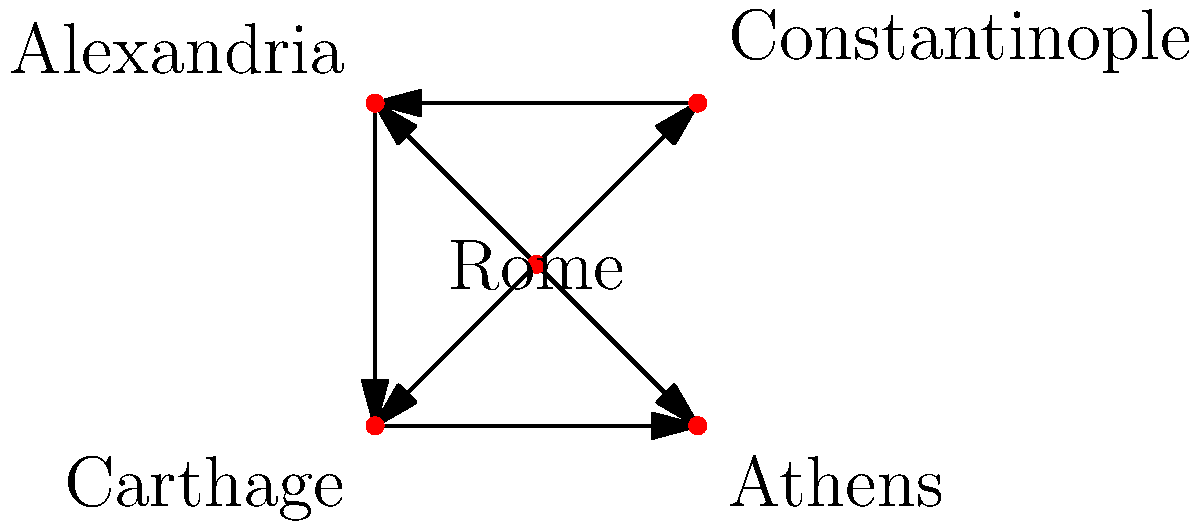In the network graph representing the spread of cultural influences through trade routes in the ancient Mediterranean world, which city appears to be the most central hub for cultural exchange? How might this centrality affect the dissemination of ideas and practices throughout the region? To answer this question, we need to analyze the network graph step-by-step:

1. Identify the nodes (cities):
   The graph shows five cities: Rome, Constantinople, Alexandria, Carthage, and Athens.

2. Examine the edges (trade routes):
   - Rome has direct connections to all other cities.
   - Other cities have fewer direct connections.

3. Count the number of connections for each city:
   - Rome: 4 connections
   - Constantinople: 2 connections
   - Alexandria: 3 connections
   - Carthage: 3 connections
   - Athens: 2 connections

4. Determine centrality:
   Rome has the highest number of direct connections, making it the most central node in the network.

5. Analyze the implications of Rome's centrality:
   a) Rome would likely receive cultural influences from all connected cities directly.
   b) Rome would serve as a intermediary for cultural exchange between other cities.
   c) Roman culture and ideas would have the most efficient pathways for spreading to other cities.
   d) The centrality of Rome aligns with historical evidence of its significant cultural impact during the Roman Empire.

6. Consider the effects on cultural dissemination:
   - Ideas, practices, and innovations from any part of the network could quickly reach Rome.
   - Rome would act as a "melting pot" of various cultural influences.
   - Roman adaptations of these influences would then be readily spread back out to the other cities.
   - This central position would reinforce Rome's role as a cultural powerhouse in the ancient Mediterranean world.
Answer: Rome; facilitates rapid and widespread cultural exchange 